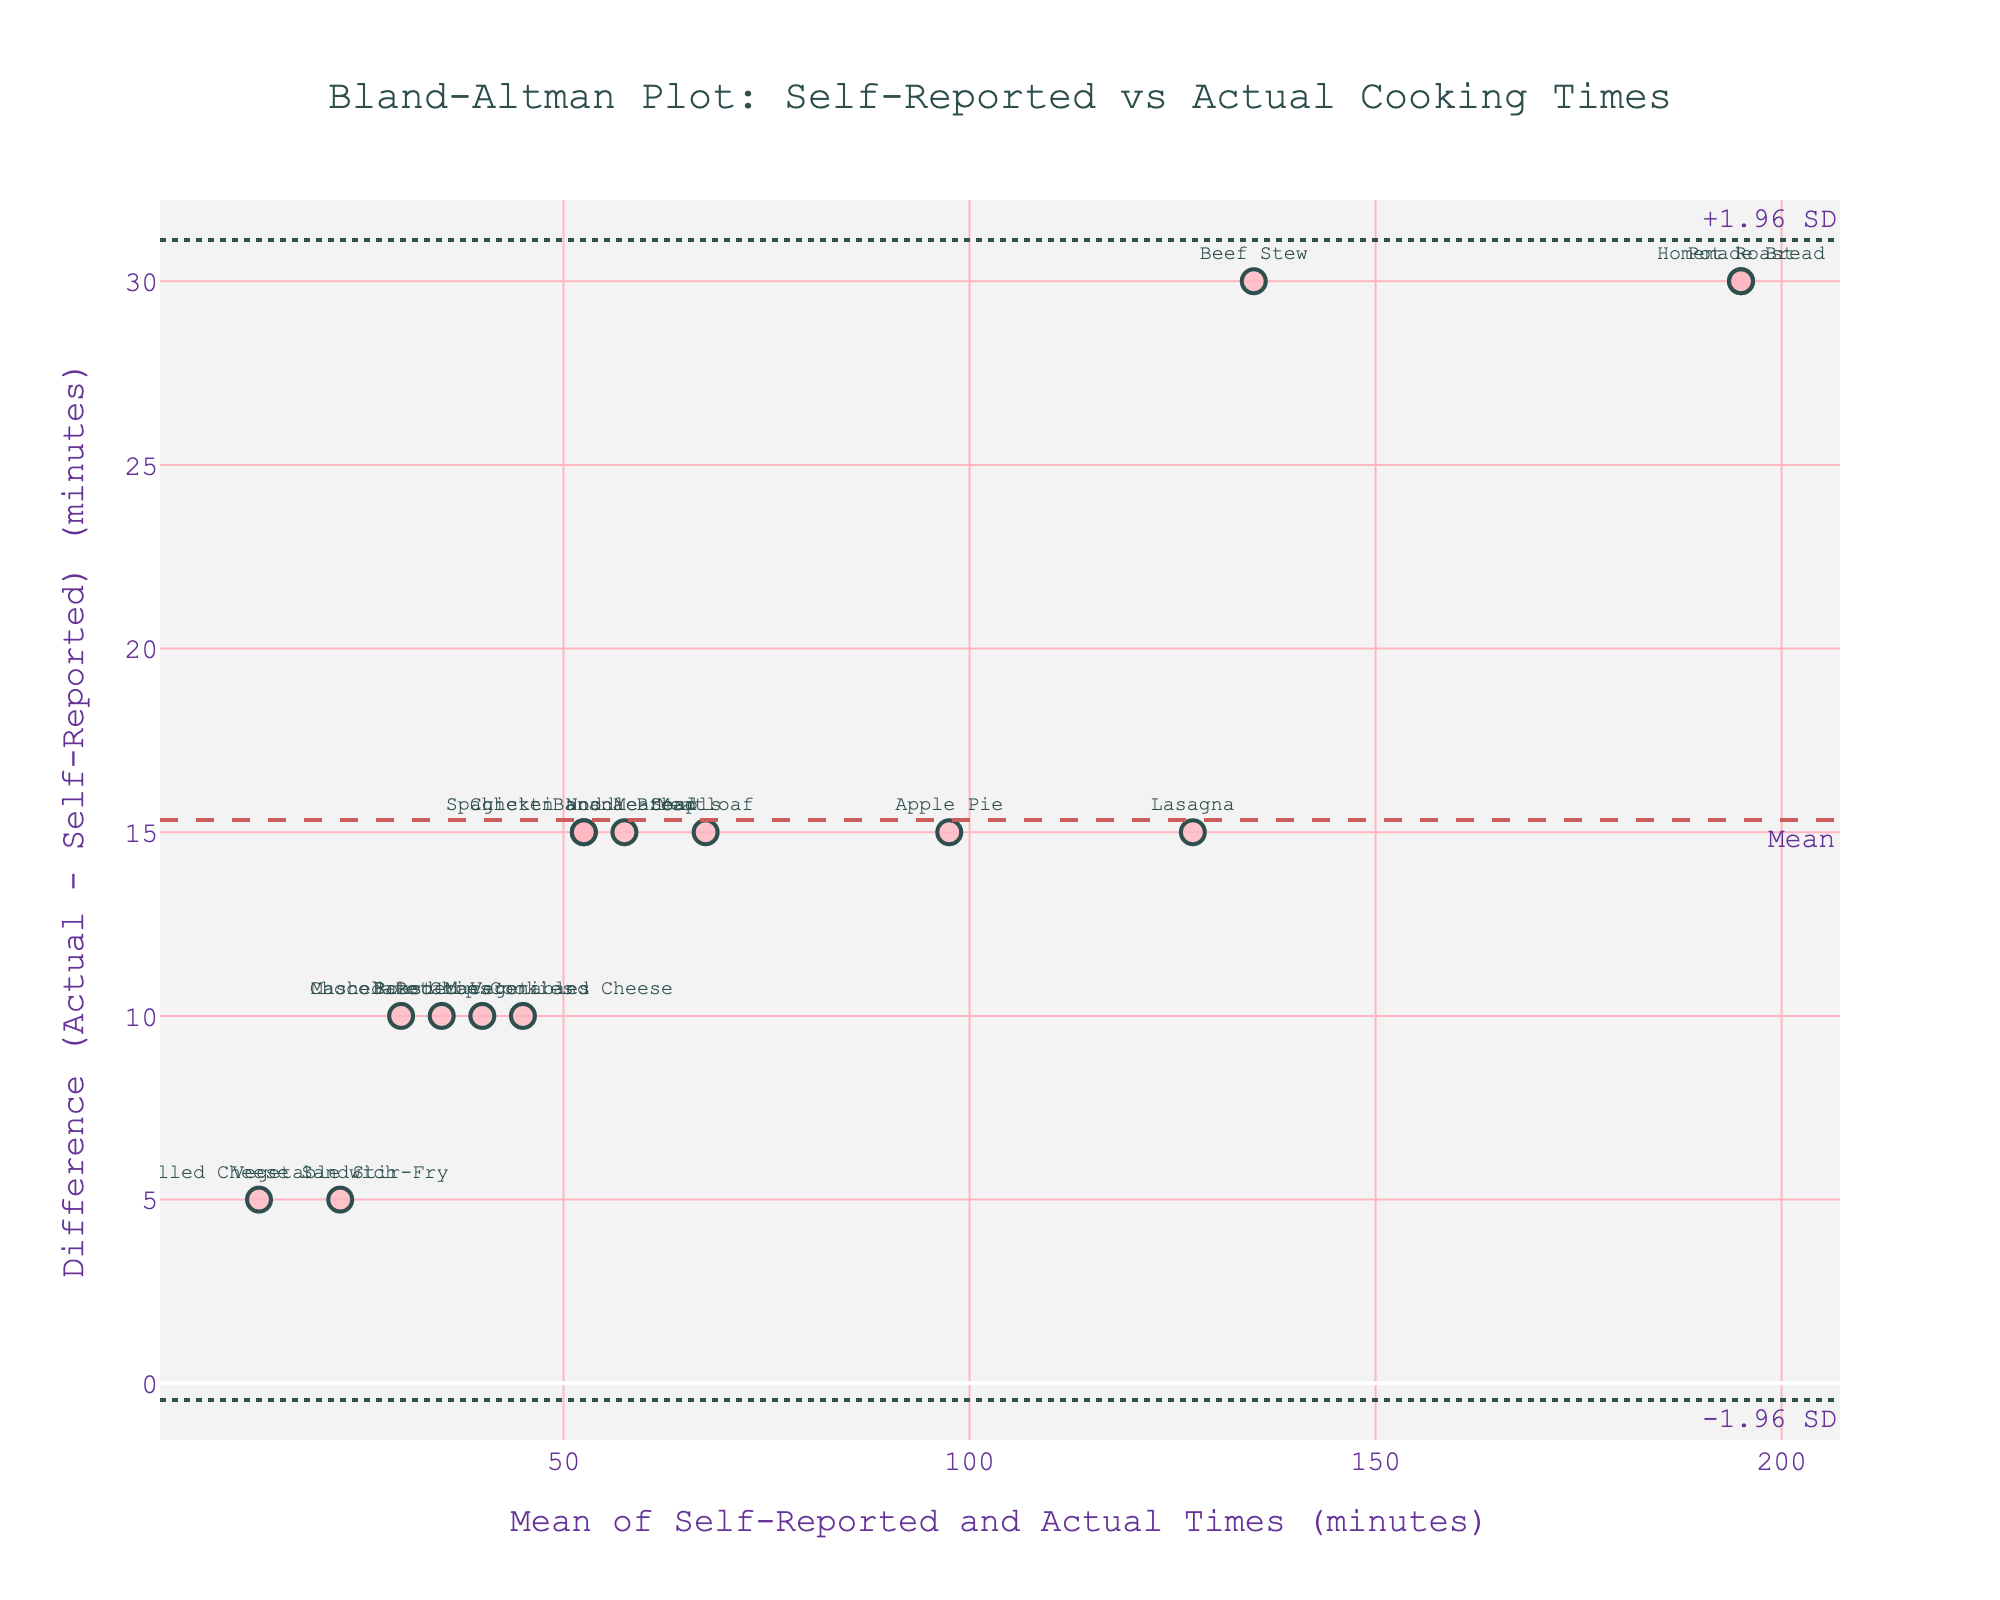what is the title of the plot? The title of the plot is typically found at the very top and summarizes the main focus of the visualization. In this case, it likely provides an overview of what the plot is comparing or demonstrating.
Answer: Bland-Altman Plot: Self-Reported vs Actual Cooking Times How many recipes are plotted in the figure? To find out how many recipes are plotted, count the number of markers or data points on the plot, with each one representing a different recipe.
Answer: 15 Which recipe has the largest positive difference between actual and self-reported cooking times? Look for the marker positioned highest above the zero line on the y-axis, indicating the largest positive difference. The accompanying text label will identify the recipe.
Answer: Pot Roast What does the dotted line labeled "+1.96 SD" represent in this context? The dotted line labeled "+1.96 SD" represents the upper limit of agreement, calculated as the mean difference plus 1.96 times the standard deviation of the differences, which typically captures 95% of the differences if they are approximately normally distributed.
Answer: Upper limit of agreement What is the mean difference between actual and self-reported cooking times? The mean difference is indicated by the dashed horizontal line labeled "Mean." This line shows the average difference between actual and self-reported times across all recipes.
Answer: 22 minutes Are there any recipes for which the self-reported and actual cooking times are equal? If the self-reported and actual cooking times are equal, the difference would be zero. Look for a marker that lies exactly on the zero line on the y-axis.
Answer: No How many recipes fall outside the limits of agreement? To determine this, count the number of markers that fall above the upper limit of agreement (+1.96 SD) and below the lower limit of agreement (-1.96 SD). These markers represent recipes with differences beyond what is typically expected.
Answer: 2 Which recipe has the smallest absolute difference between actual and self-reported times? The smallest absolute difference is indicated by the marker closest to the zero line on the y-axis. Look at the text label corresponding to this marker.
Answer: Vegetable Stir-Fry Does the mean of self-reported and actual cooking times trend higher for recipes with larger differences? To answer this, observe whether recipes with larger differences tend to have higher mean values on the x-axis. This involves examining if the points with larger y-values (differences) also have larger x-values (means).
Answer: Yes What is the range of the actual cooking times? Actual cooking times are the y-values in the plotted data. Locate the minimum and maximum markers on the y-axis to find the range. Specifically, from the lowest to the highest data point labeled with actual times.
Answer: 15 to 210 minutes 